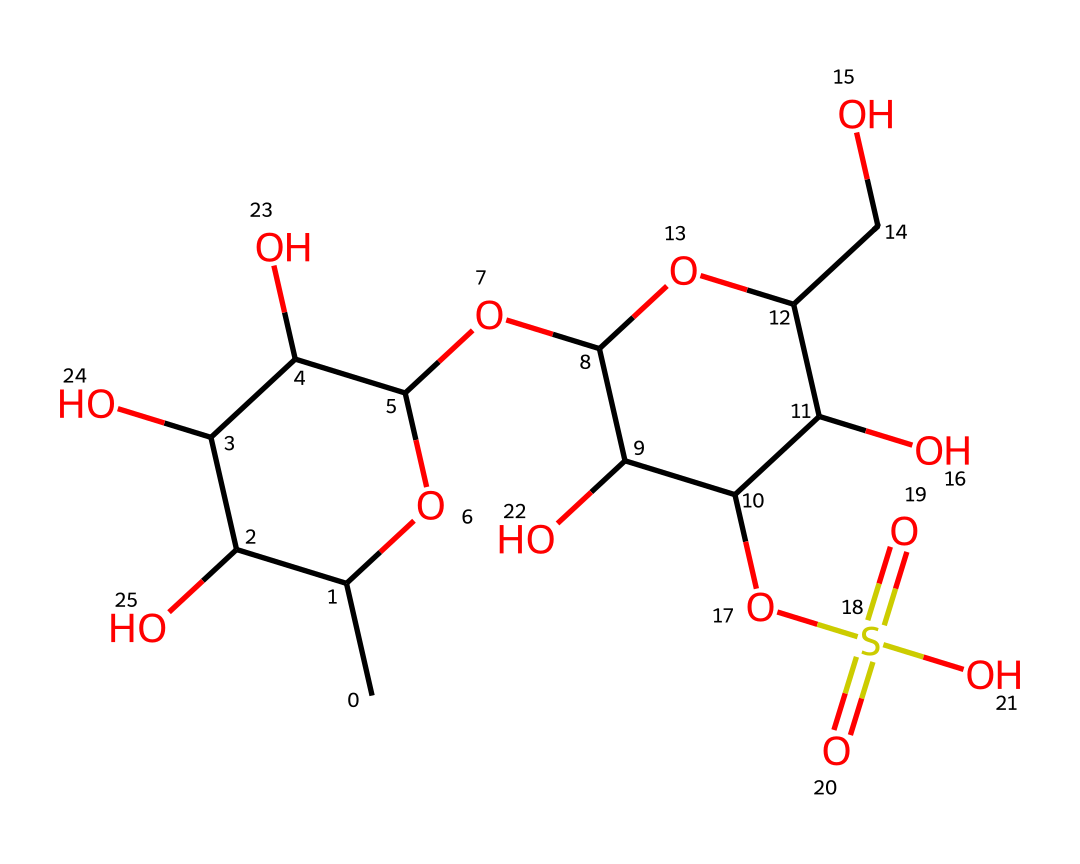What is the main type of carbohydrate in this structure? This structure primarily consists of polysaccharides, particularly galactose and a sulfate group that indicates it is a sulfated polysaccharide derived from red algae.
Answer: polysaccharide How many hydroxyl (OH) groups are present in this molecule? By examining the structure, you can identify multiple functional groups. Each -OH group can be counted, and in this case, there are five -OH groups present in the molecule.
Answer: five What element does the S in the SO3 group represent? In the sulfate functional group (SO3), the 'S' represents sulfur, which is a key element in forming sulfated polysaccharides.
Answer: sulfur Is this chemical soluble in water? Due to the presence of numerous hydroxyl groups and a sulfate group, this compound is expected to be hydrophilic and soluble in water.
Answer: yes What type of non-Newtonian behavior does carrageenan exhibit in solution? Carrageenan behaves as a shear-thinning fluid in solutions, which means it becomes less viscous under applied stress or shear.
Answer: shear-thinning What does the sulfate group contribute to the properties of this ingredient? The sulfate group not only contributes to the polarity of carrageenan but also enhances its ability to form gels under specific conditions, which is crucial for its use in cosmetics.
Answer: gel-forming 